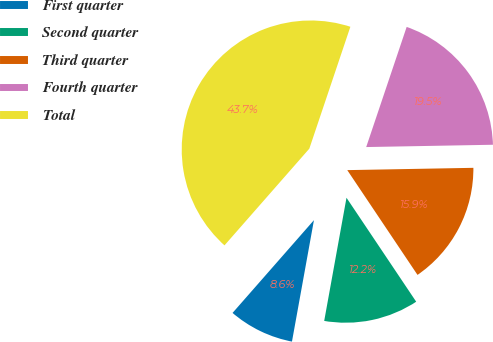Convert chart. <chart><loc_0><loc_0><loc_500><loc_500><pie_chart><fcel>First quarter<fcel>Second quarter<fcel>Third quarter<fcel>Fourth quarter<fcel>Total<nl><fcel>8.61%<fcel>12.25%<fcel>15.89%<fcel>19.54%<fcel>43.71%<nl></chart> 